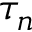<formula> <loc_0><loc_0><loc_500><loc_500>\tau _ { n }</formula> 